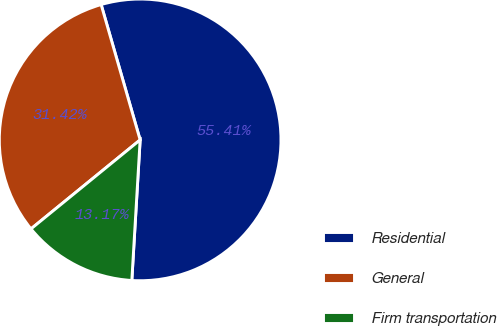Convert chart. <chart><loc_0><loc_0><loc_500><loc_500><pie_chart><fcel>Residential<fcel>General<fcel>Firm transportation<nl><fcel>55.41%<fcel>31.42%<fcel>13.17%<nl></chart> 